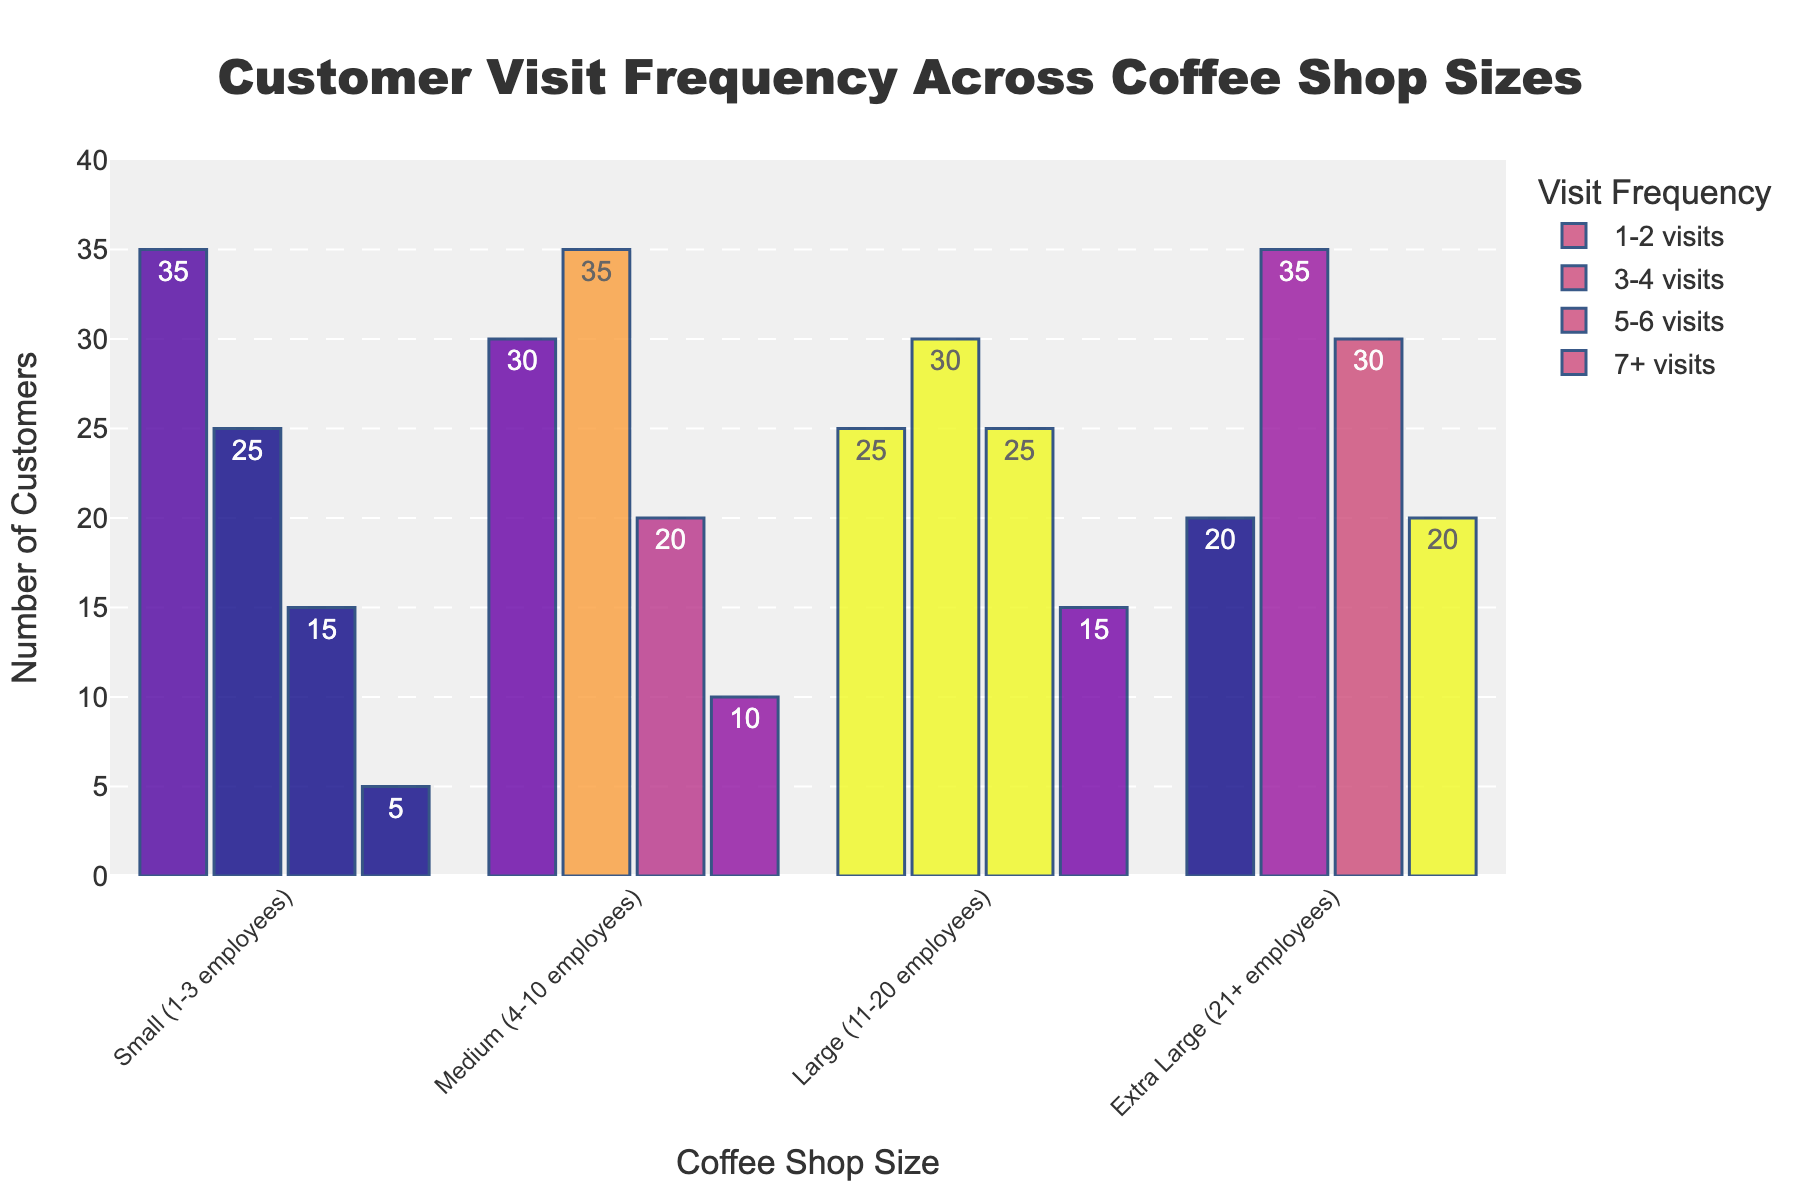Which coffee shop size has the highest number of customers who visit 7+ times a week? The "Extra Large (21+ employees)" coffee shop size has a bar indicating 20 customers. This is higher than any other shop size in that category.
Answer: Extra Large Which visit frequency category sees the highest number of total customers across all coffee shop sizes? Sum the number of customers in each shop size for all visit frequencies. For 1-2 visits: 35+30+25+20 = 110. For 3-4 visits: 25+35+30+35 = 125. For 5-6 visits: 15+20+25+30 = 90. For 7+ visits: 5+10+15+20 = 50. The highest total is in the 3-4 visits category.
Answer: 3-4 visits What is the combined number of customers who visit 3-4 and 5-6 times a week in Medium coffee shops? For Medium coffee shops, add the number of customers in the 3-4 visits (35) and 5-6 visits (20) categories. This gives 35+20 = 55.
Answer: 55 Which coffee shop size has the fewest number of customers for 1-2 visits? By looking at the height of the bars, the Extra Large shop size has the fewest (20) customers for 1-2 visits compared to the other sizes which have 35, 30, and 25 customers.
Answer: Extra Large Compare the total number of customers in Small and Large coffee shops across all visit frequencies. Which size has more total customers? Sum the total number of customers for Small shops (35+25+15+5 = 80) and for Large shops (25+30+25+15 = 95). Compare the totals; Large coffee shops have more (95 vs. 80).
Answer: Large In which visit category are the customer numbers equally distributed between Medium and Large coffee shops? The visit category 5-6 has 20 customers each in both Medium and Large coffee shops, making it equally distributed.
Answer: 5-6 visits Which coffee shop size has the most significant increase in customer visits when moving from the 5-6 visits category to the 7+ visits category? For Small: 15 to 5 (decrease), Medium: 20 to 10 (decrease), Large: 25 to 15 (decrease), Extra Large: 30 to 20 (decrease). They all decrease, but the smallest decrease is in Small shops (-10). Thus, no increase is noted, only the smallest decrease.
Answer: None What is the ratio of customers who visit 7+ times to those who visit 1-2 times in Large coffee shops? For Large shops, divide the number of customers who visit 7+ times (15) by those who visit 1-2 times (25). The ratio is 15/25 = 0.6.
Answer: 0.6 Between Medium and Extra Large coffee shops, which has a higher average number of customers across all visit frequencies? Calculate the average number of customers for each shop size. Medium: (30+35+20+10)/4 = 23.75, Extra Large: (20+35+30+20)/4 = 26.25. Extra Large has a higher average.
Answer: Extra Large 